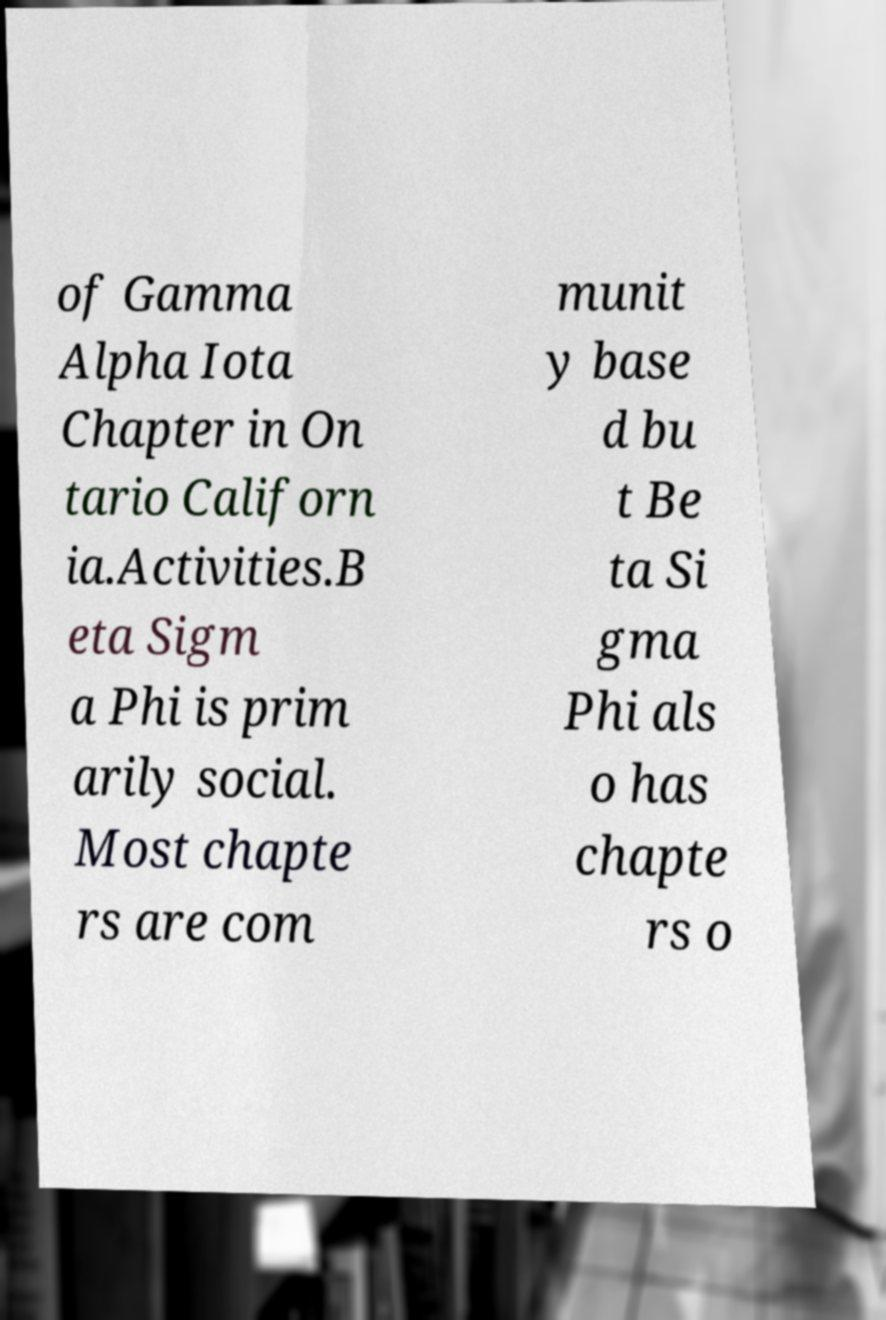There's text embedded in this image that I need extracted. Can you transcribe it verbatim? of Gamma Alpha Iota Chapter in On tario Californ ia.Activities.B eta Sigm a Phi is prim arily social. Most chapte rs are com munit y base d bu t Be ta Si gma Phi als o has chapte rs o 